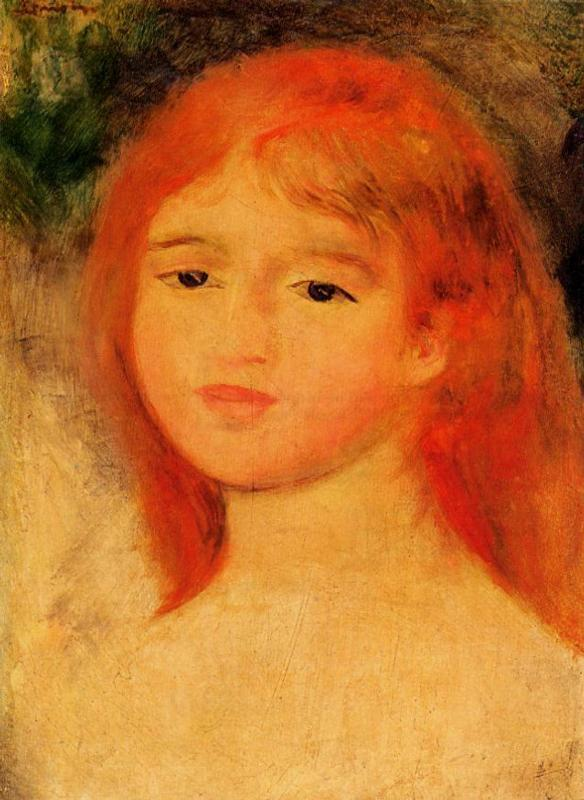What do you see happening in this image? The image is an impressionist portrait of a young girl, notable for her striking red hair and the contemplative mood evoked. Painted with broad, expressive brushstrokes typical of the impressionist movement, the artist focuses on capturing fleeting qualities of light and color rather than detailed realism. The background, a softened blend of greens and yellows with a hint of blue, complements the warm tones of her hair and the delicate blush on her cheeks, suggesting a live, dynamic interplay of colors. Overall, this portrait marvelously captures the subtleties of human expression and the beauty of impressionist art. 